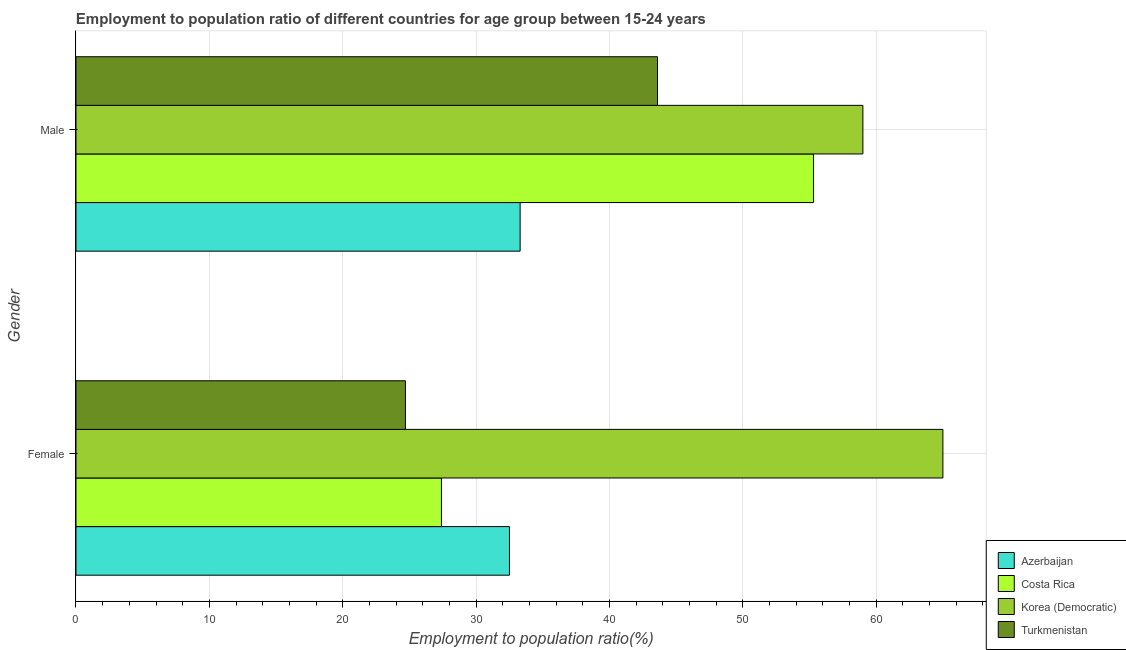Are the number of bars per tick equal to the number of legend labels?
Your answer should be compact. Yes. Are the number of bars on each tick of the Y-axis equal?
Provide a short and direct response. Yes. How many bars are there on the 2nd tick from the top?
Keep it short and to the point. 4. What is the employment to population ratio(female) in Turkmenistan?
Ensure brevity in your answer.  24.7. Across all countries, what is the maximum employment to population ratio(male)?
Make the answer very short. 59. Across all countries, what is the minimum employment to population ratio(male)?
Provide a succinct answer. 33.3. In which country was the employment to population ratio(male) maximum?
Offer a terse response. Korea (Democratic). In which country was the employment to population ratio(female) minimum?
Give a very brief answer. Turkmenistan. What is the total employment to population ratio(male) in the graph?
Provide a short and direct response. 191.2. What is the difference between the employment to population ratio(female) in Korea (Democratic) and that in Costa Rica?
Offer a very short reply. 37.6. What is the difference between the employment to population ratio(male) in Korea (Democratic) and the employment to population ratio(female) in Costa Rica?
Your answer should be very brief. 31.6. What is the average employment to population ratio(male) per country?
Offer a terse response. 47.8. What is the difference between the employment to population ratio(male) and employment to population ratio(female) in Turkmenistan?
Keep it short and to the point. 18.9. In how many countries, is the employment to population ratio(male) greater than 56 %?
Your answer should be very brief. 1. What is the ratio of the employment to population ratio(female) in Turkmenistan to that in Costa Rica?
Ensure brevity in your answer.  0.9. What does the 4th bar from the top in Female represents?
Offer a terse response. Azerbaijan. What does the 1st bar from the bottom in Male represents?
Provide a short and direct response. Azerbaijan. Are all the bars in the graph horizontal?
Offer a terse response. Yes. What is the title of the graph?
Your answer should be very brief. Employment to population ratio of different countries for age group between 15-24 years. Does "Samoa" appear as one of the legend labels in the graph?
Your response must be concise. No. What is the label or title of the X-axis?
Ensure brevity in your answer.  Employment to population ratio(%). What is the Employment to population ratio(%) in Azerbaijan in Female?
Offer a very short reply. 32.5. What is the Employment to population ratio(%) of Costa Rica in Female?
Give a very brief answer. 27.4. What is the Employment to population ratio(%) of Turkmenistan in Female?
Provide a succinct answer. 24.7. What is the Employment to population ratio(%) of Azerbaijan in Male?
Keep it short and to the point. 33.3. What is the Employment to population ratio(%) of Costa Rica in Male?
Offer a very short reply. 55.3. What is the Employment to population ratio(%) in Korea (Democratic) in Male?
Offer a terse response. 59. What is the Employment to population ratio(%) of Turkmenistan in Male?
Provide a succinct answer. 43.6. Across all Gender, what is the maximum Employment to population ratio(%) in Azerbaijan?
Your answer should be compact. 33.3. Across all Gender, what is the maximum Employment to population ratio(%) in Costa Rica?
Make the answer very short. 55.3. Across all Gender, what is the maximum Employment to population ratio(%) of Turkmenistan?
Offer a terse response. 43.6. Across all Gender, what is the minimum Employment to population ratio(%) in Azerbaijan?
Keep it short and to the point. 32.5. Across all Gender, what is the minimum Employment to population ratio(%) of Costa Rica?
Give a very brief answer. 27.4. Across all Gender, what is the minimum Employment to population ratio(%) in Turkmenistan?
Give a very brief answer. 24.7. What is the total Employment to population ratio(%) in Azerbaijan in the graph?
Make the answer very short. 65.8. What is the total Employment to population ratio(%) of Costa Rica in the graph?
Make the answer very short. 82.7. What is the total Employment to population ratio(%) of Korea (Democratic) in the graph?
Offer a very short reply. 124. What is the total Employment to population ratio(%) in Turkmenistan in the graph?
Give a very brief answer. 68.3. What is the difference between the Employment to population ratio(%) in Costa Rica in Female and that in Male?
Ensure brevity in your answer.  -27.9. What is the difference between the Employment to population ratio(%) of Korea (Democratic) in Female and that in Male?
Provide a succinct answer. 6. What is the difference between the Employment to population ratio(%) in Turkmenistan in Female and that in Male?
Provide a succinct answer. -18.9. What is the difference between the Employment to population ratio(%) of Azerbaijan in Female and the Employment to population ratio(%) of Costa Rica in Male?
Offer a very short reply. -22.8. What is the difference between the Employment to population ratio(%) of Azerbaijan in Female and the Employment to population ratio(%) of Korea (Democratic) in Male?
Provide a short and direct response. -26.5. What is the difference between the Employment to population ratio(%) of Azerbaijan in Female and the Employment to population ratio(%) of Turkmenistan in Male?
Offer a terse response. -11.1. What is the difference between the Employment to population ratio(%) in Costa Rica in Female and the Employment to population ratio(%) in Korea (Democratic) in Male?
Your response must be concise. -31.6. What is the difference between the Employment to population ratio(%) of Costa Rica in Female and the Employment to population ratio(%) of Turkmenistan in Male?
Offer a very short reply. -16.2. What is the difference between the Employment to population ratio(%) of Korea (Democratic) in Female and the Employment to population ratio(%) of Turkmenistan in Male?
Keep it short and to the point. 21.4. What is the average Employment to population ratio(%) in Azerbaijan per Gender?
Your response must be concise. 32.9. What is the average Employment to population ratio(%) of Costa Rica per Gender?
Offer a terse response. 41.35. What is the average Employment to population ratio(%) of Turkmenistan per Gender?
Give a very brief answer. 34.15. What is the difference between the Employment to population ratio(%) of Azerbaijan and Employment to population ratio(%) of Korea (Democratic) in Female?
Provide a succinct answer. -32.5. What is the difference between the Employment to population ratio(%) of Costa Rica and Employment to population ratio(%) of Korea (Democratic) in Female?
Give a very brief answer. -37.6. What is the difference between the Employment to population ratio(%) of Costa Rica and Employment to population ratio(%) of Turkmenistan in Female?
Your answer should be very brief. 2.7. What is the difference between the Employment to population ratio(%) of Korea (Democratic) and Employment to population ratio(%) of Turkmenistan in Female?
Make the answer very short. 40.3. What is the difference between the Employment to population ratio(%) of Azerbaijan and Employment to population ratio(%) of Korea (Democratic) in Male?
Offer a very short reply. -25.7. What is the difference between the Employment to population ratio(%) in Azerbaijan and Employment to population ratio(%) in Turkmenistan in Male?
Keep it short and to the point. -10.3. What is the difference between the Employment to population ratio(%) in Costa Rica and Employment to population ratio(%) in Korea (Democratic) in Male?
Provide a succinct answer. -3.7. What is the difference between the Employment to population ratio(%) of Costa Rica and Employment to population ratio(%) of Turkmenistan in Male?
Your answer should be very brief. 11.7. What is the difference between the Employment to population ratio(%) of Korea (Democratic) and Employment to population ratio(%) of Turkmenistan in Male?
Provide a succinct answer. 15.4. What is the ratio of the Employment to population ratio(%) in Costa Rica in Female to that in Male?
Make the answer very short. 0.5. What is the ratio of the Employment to population ratio(%) of Korea (Democratic) in Female to that in Male?
Provide a succinct answer. 1.1. What is the ratio of the Employment to population ratio(%) in Turkmenistan in Female to that in Male?
Make the answer very short. 0.57. What is the difference between the highest and the second highest Employment to population ratio(%) of Azerbaijan?
Offer a terse response. 0.8. What is the difference between the highest and the second highest Employment to population ratio(%) in Costa Rica?
Ensure brevity in your answer.  27.9. What is the difference between the highest and the lowest Employment to population ratio(%) in Azerbaijan?
Give a very brief answer. 0.8. What is the difference between the highest and the lowest Employment to population ratio(%) of Costa Rica?
Offer a terse response. 27.9. What is the difference between the highest and the lowest Employment to population ratio(%) in Turkmenistan?
Offer a terse response. 18.9. 